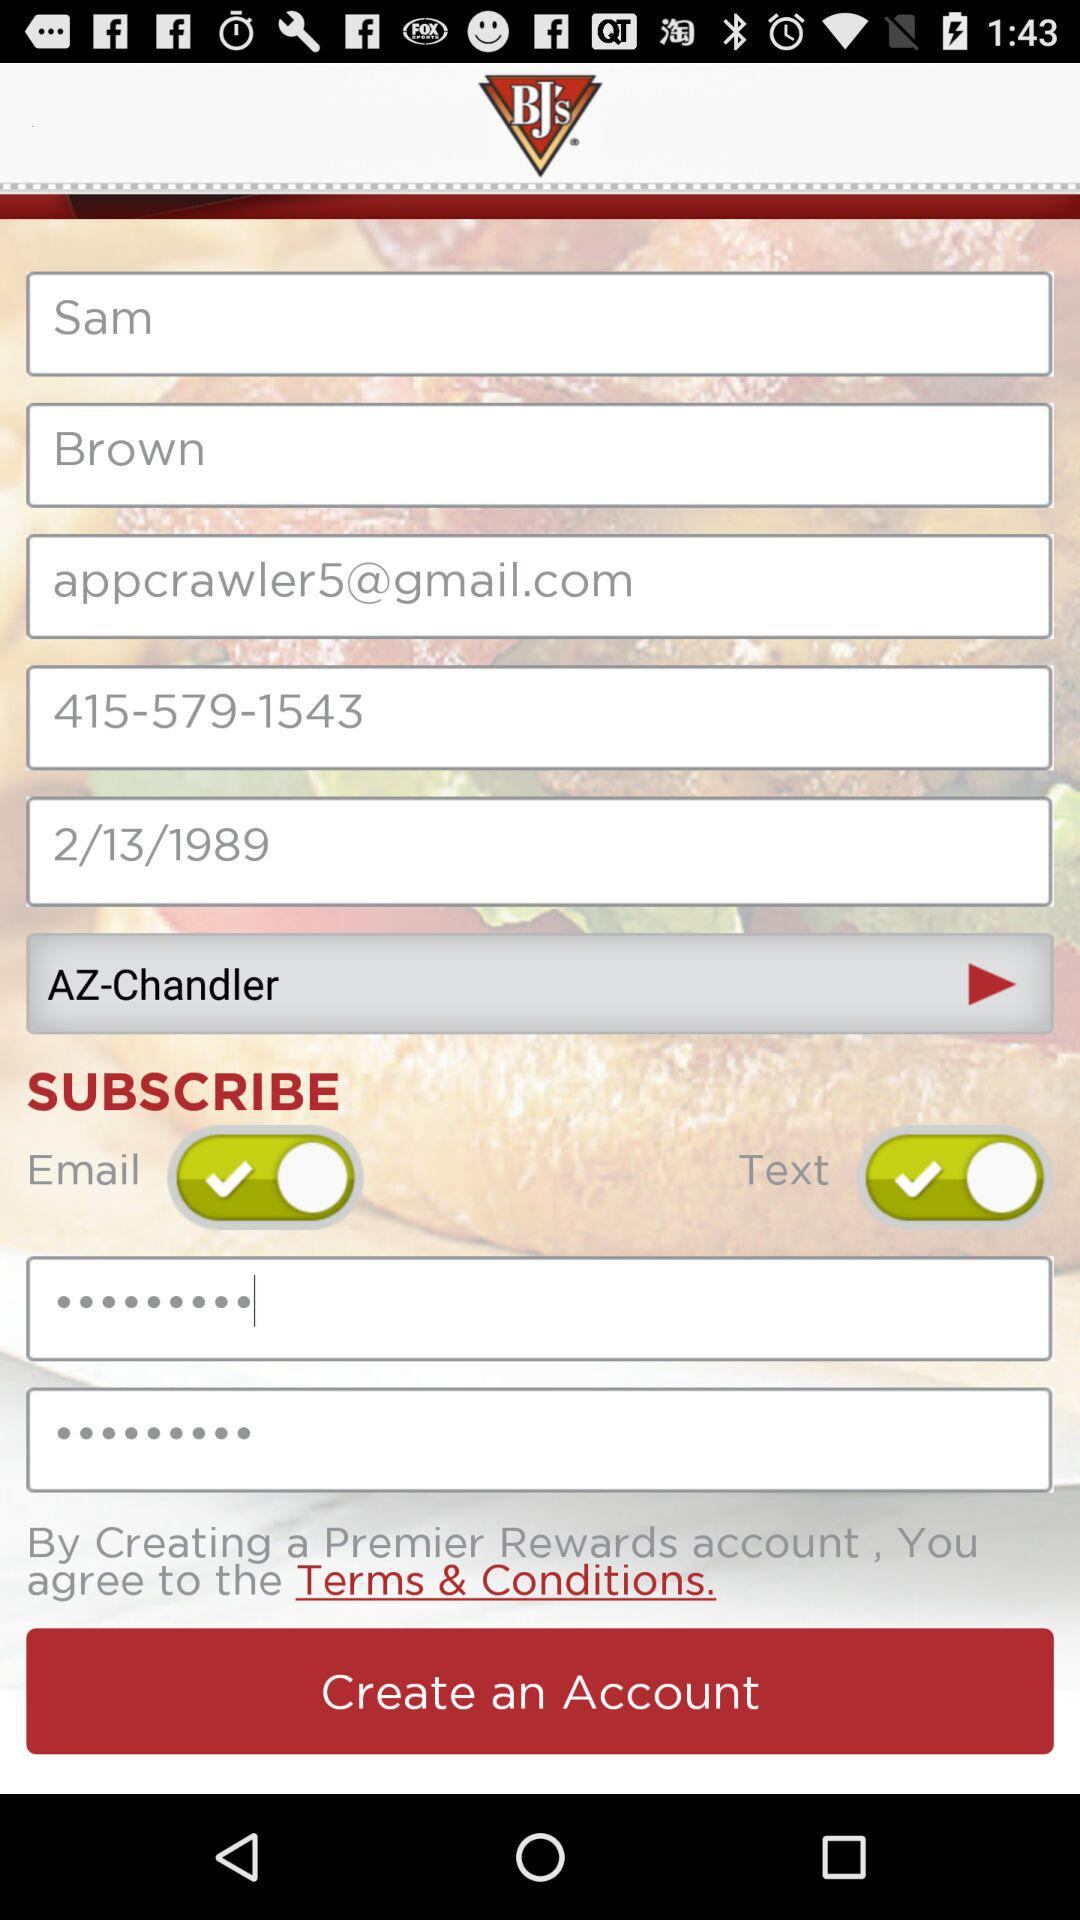What is the entered date? The entered date is February 13, 1989. 